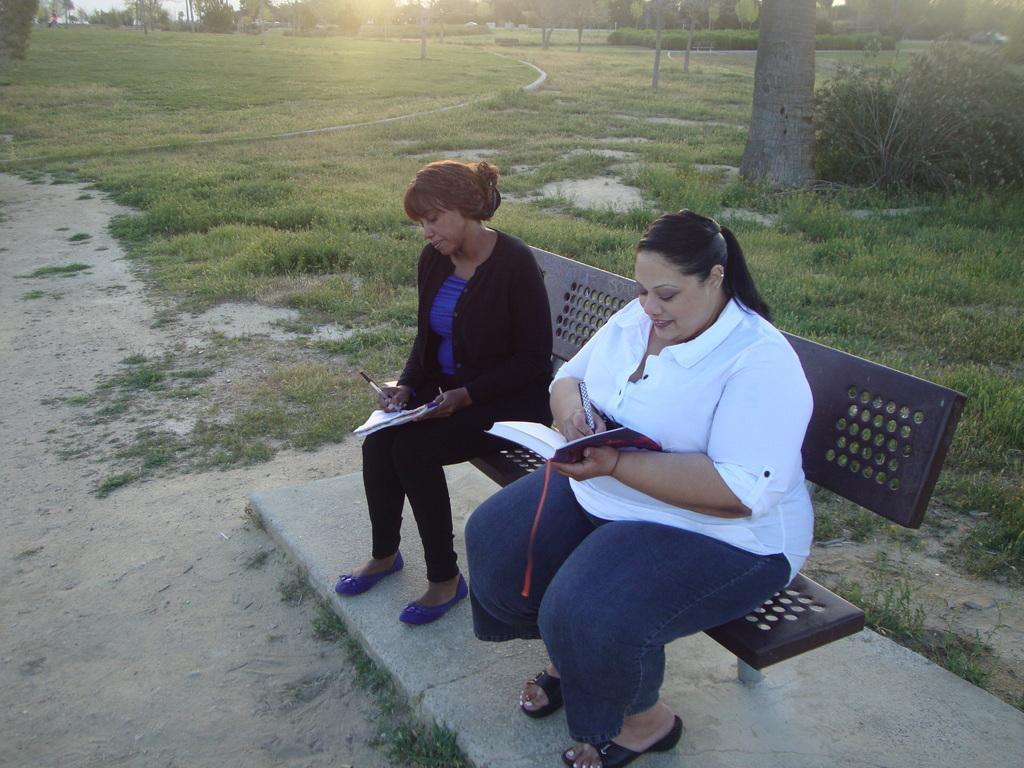How would you summarize this image in a sentence or two? In this image we can see two women are sitting on the bench and holding a book and pen in their hands. In the background we can see trees and shrubs. 